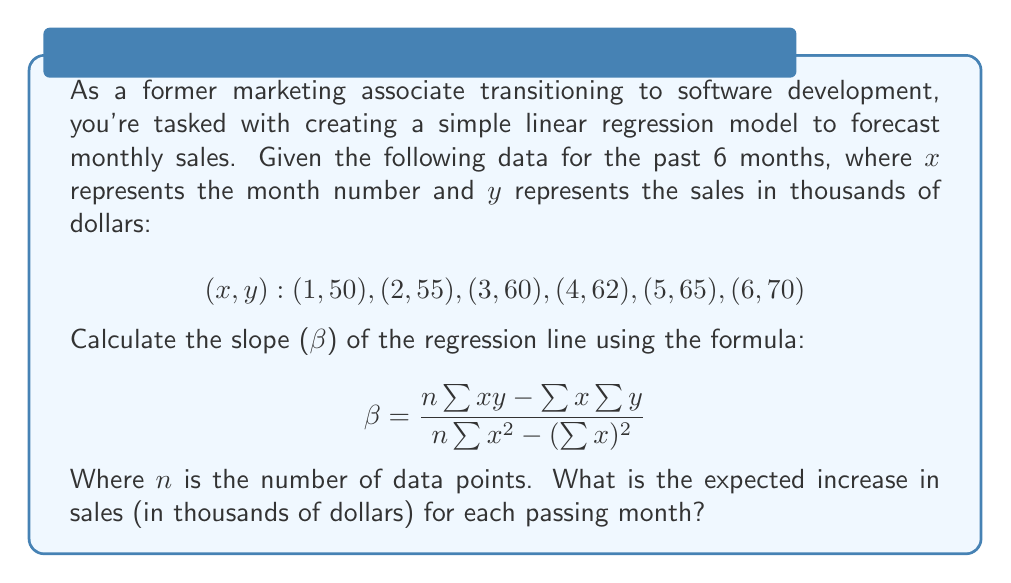Can you answer this question? Let's solve this step-by-step:

1) First, we need to calculate the sums required for the formula:
   $n = 6$ (number of data points)
   $\sum x = 1 + 2 + 3 + 4 + 5 + 6 = 21$
   $\sum y = 50 + 55 + 60 + 62 + 65 + 70 = 362$
   $\sum xy = (1)(50) + (2)(55) + (3)(60) + (4)(62) + (5)(65) + (6)(70) = 1,385$
   $\sum x^2 = 1^2 + 2^2 + 3^2 + 4^2 + 5^2 + 6^2 = 91$

2) Now, let's substitute these values into the formula:

   $$\beta = \frac{n\sum xy - \sum x \sum y}{n\sum x^2 - (\sum x)^2}$$

   $$\beta = \frac{6(1,385) - (21)(362)}{6(91) - (21)^2}$$

3) Let's calculate the numerator and denominator separately:
   Numerator: $6(1,385) - (21)(362) = 8,310 - 7,602 = 708$
   Denominator: $6(91) - (21)^2 = 546 - 441 = 105$

4) Now, we can divide:
   $$\beta = \frac{708}{105} = 6.74285714...$$

5) Rounding to two decimal places for practical use:
   $$\beta ≈ 6.74$$

This slope represents the average increase in sales (in thousands of dollars) for each passing month.
Answer: $6.74$ thousand dollars 